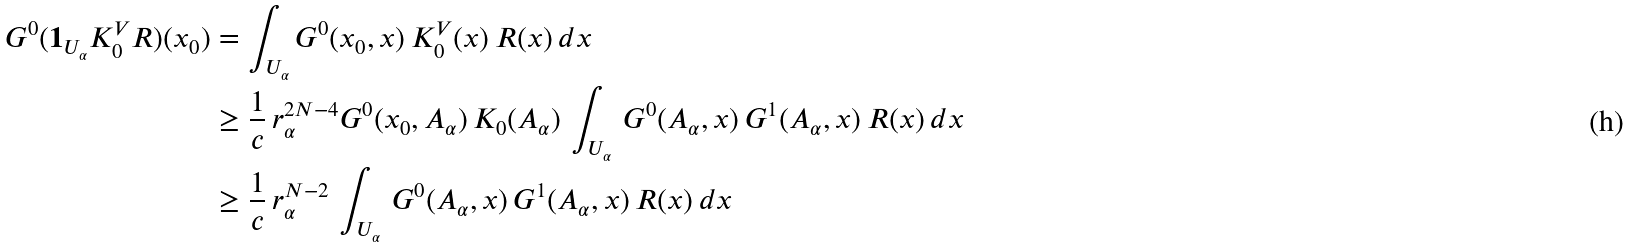<formula> <loc_0><loc_0><loc_500><loc_500>G ^ { 0 } ( { \mathbf 1 } _ { U _ { \alpha } } K _ { 0 } ^ { V } R ) ( x _ { 0 } ) & = \int _ { U _ { \alpha } } G ^ { 0 } ( x _ { 0 } , x ) \, K _ { 0 } ^ { V } ( x ) \, R ( x ) \, d x \\ & \geq { \frac { 1 } { c } } \, r _ { \alpha } ^ { 2 N - 4 } G ^ { 0 } ( x _ { 0 } , A _ { \alpha } ) \, K _ { 0 } ( A _ { \alpha } ) \, \int _ { U _ { \alpha } } \, G ^ { 0 } ( A _ { \alpha } , x ) \, G ^ { 1 } ( A _ { \alpha } , x ) \, R ( x ) \, d x \\ & \geq { \frac { 1 } { c } } \, r _ { \alpha } ^ { N - 2 } \, \int _ { U _ { \alpha } } \, G ^ { 0 } ( A _ { \alpha } , x ) \, G ^ { 1 } ( A _ { \alpha } , x ) \, R ( x ) \, d x</formula> 